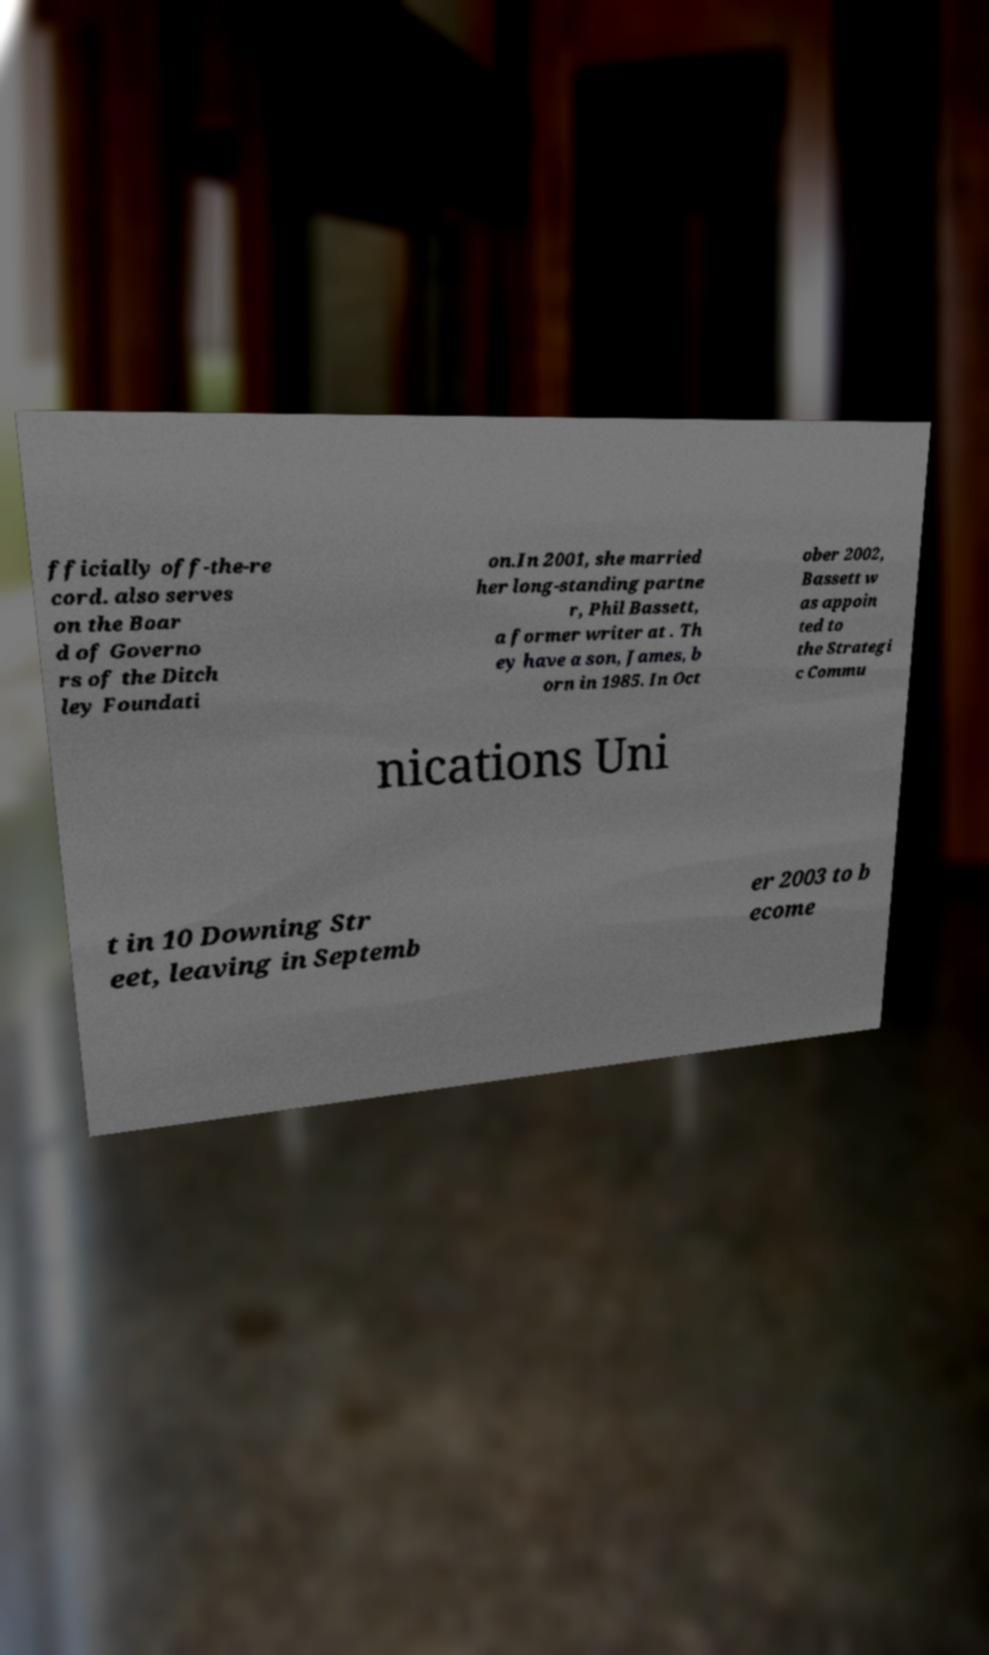I need the written content from this picture converted into text. Can you do that? fficially off-the-re cord. also serves on the Boar d of Governo rs of the Ditch ley Foundati on.In 2001, she married her long-standing partne r, Phil Bassett, a former writer at . Th ey have a son, James, b orn in 1985. In Oct ober 2002, Bassett w as appoin ted to the Strategi c Commu nications Uni t in 10 Downing Str eet, leaving in Septemb er 2003 to b ecome 